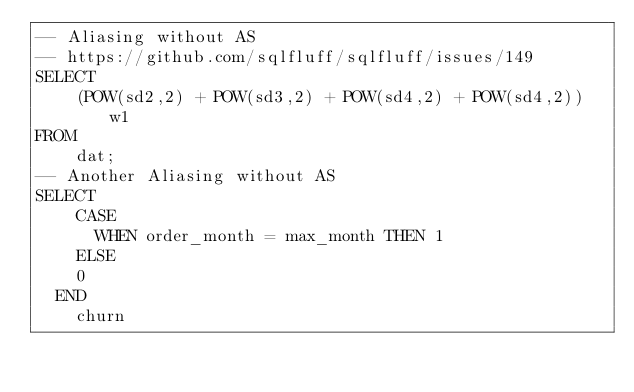Convert code to text. <code><loc_0><loc_0><loc_500><loc_500><_SQL_>-- Aliasing without AS
-- https://github.com/sqlfluff/sqlfluff/issues/149
SELECT
    (POW(sd2,2) + POW(sd3,2) + POW(sd4,2) + POW(sd4,2)) w1
FROM
    dat;
-- Another Aliasing without AS
SELECT
    CASE
      WHEN order_month = max_month THEN 1
    ELSE
    0
  END
    churn</code> 